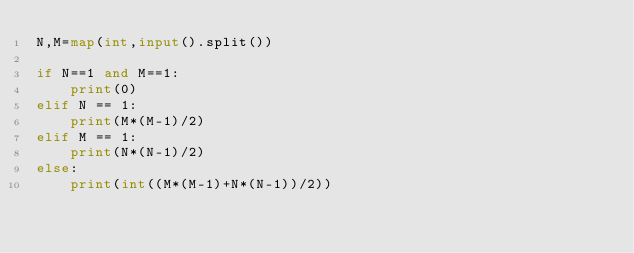Convert code to text. <code><loc_0><loc_0><loc_500><loc_500><_Python_>N,M=map(int,input().split())

if N==1 and M==1:
    print(0)
elif N == 1:
    print(M*(M-1)/2)
elif M == 1:
    print(N*(N-1)/2)
else:
    print(int((M*(M-1)+N*(N-1))/2))</code> 